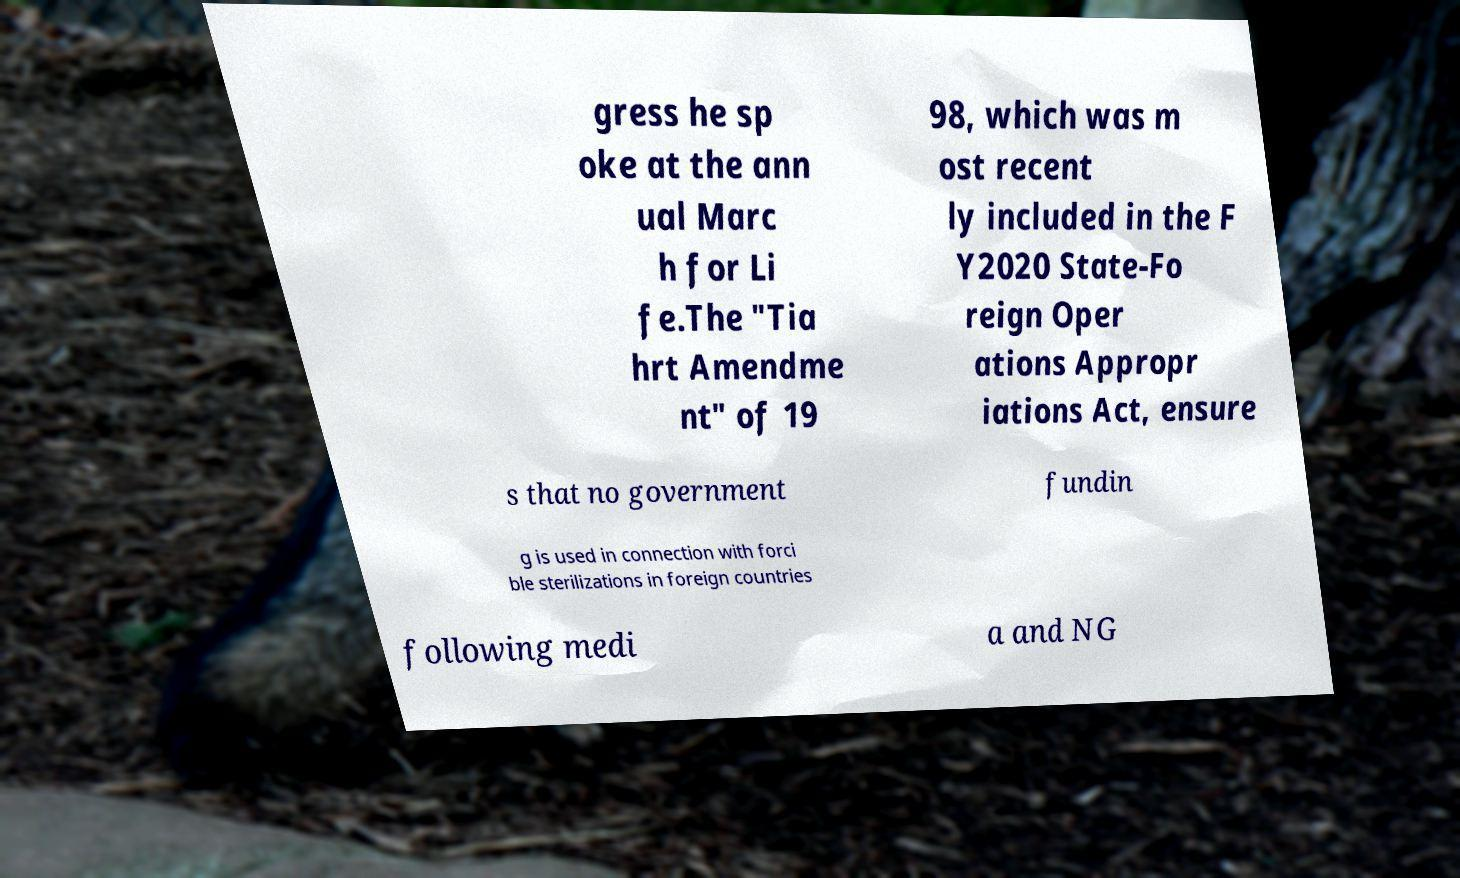For documentation purposes, I need the text within this image transcribed. Could you provide that? gress he sp oke at the ann ual Marc h for Li fe.The "Tia hrt Amendme nt" of 19 98, which was m ost recent ly included in the F Y2020 State-Fo reign Oper ations Appropr iations Act, ensure s that no government fundin g is used in connection with forci ble sterilizations in foreign countries following medi a and NG 